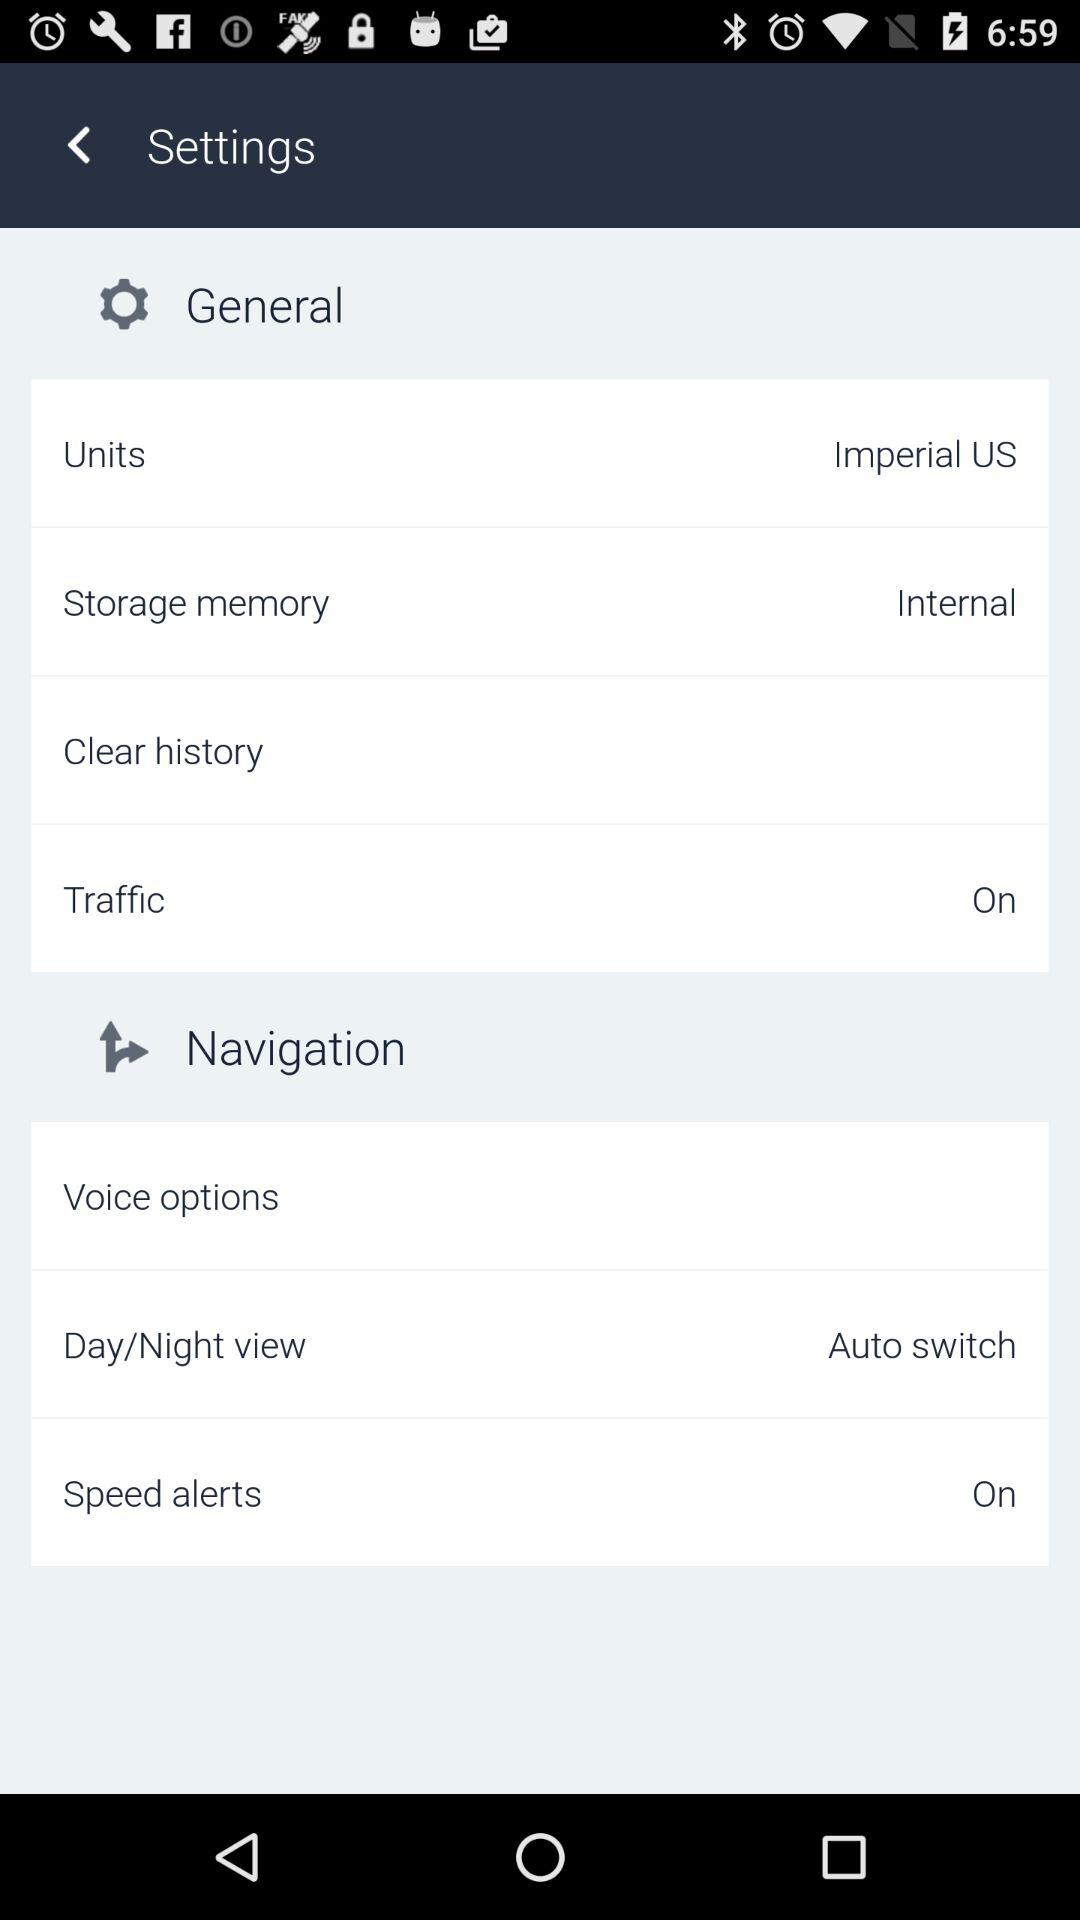How many items have a text value of 'On'?
Answer the question using a single word or phrase. 2 